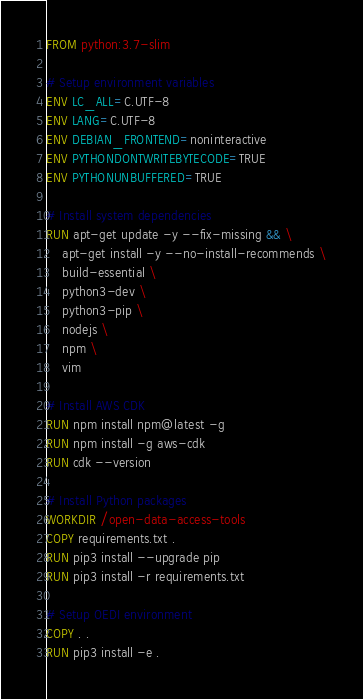Convert code to text. <code><loc_0><loc_0><loc_500><loc_500><_Dockerfile_>FROM python:3.7-slim

# Setup environment variables
ENV LC_ALL=C.UTF-8
ENV LANG=C.UTF-8
ENV DEBIAN_FRONTEND=noninteractive
ENV PYTHONDONTWRITEBYTECODE=TRUE
ENV PYTHONUNBUFFERED=TRUE

# Install system dependencies
RUN apt-get update -y --fix-missing && \
    apt-get install -y --no-install-recommends \
    build-essential \
    python3-dev \
    python3-pip \
    nodejs \
    npm \
    vim

# Install AWS CDK
RUN npm install npm@latest -g
RUN npm install -g aws-cdk
RUN cdk --version

# Install Python packages
WORKDIR /open-data-access-tools
COPY requirements.txt .
RUN pip3 install --upgrade pip
RUN pip3 install -r requirements.txt

# Setup OEDI environment
COPY . .
RUN pip3 install -e .
</code> 